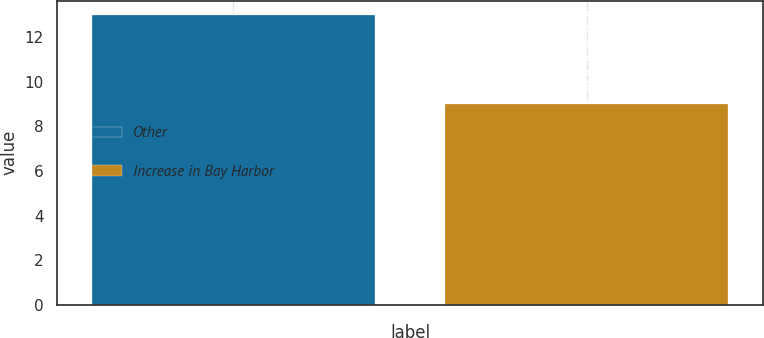<chart> <loc_0><loc_0><loc_500><loc_500><bar_chart><fcel>Other<fcel>Increase in Bay Harbor<nl><fcel>13<fcel>9<nl></chart> 